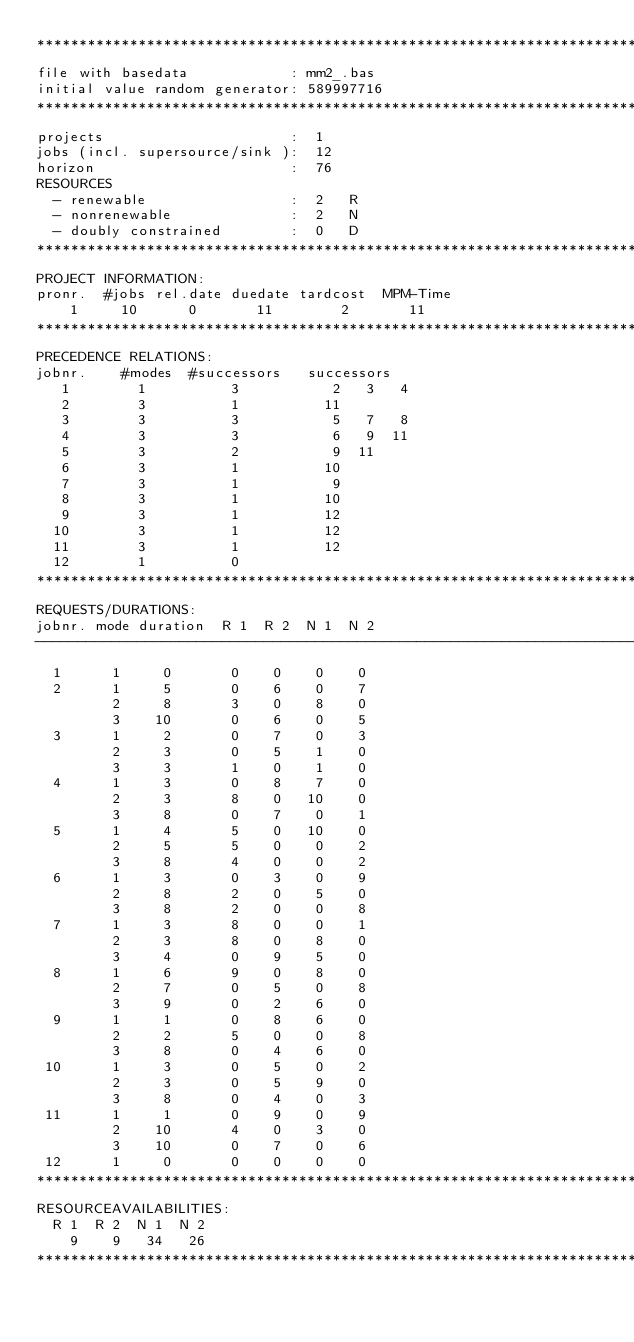<code> <loc_0><loc_0><loc_500><loc_500><_ObjectiveC_>************************************************************************
file with basedata            : mm2_.bas
initial value random generator: 589997716
************************************************************************
projects                      :  1
jobs (incl. supersource/sink ):  12
horizon                       :  76
RESOURCES
  - renewable                 :  2   R
  - nonrenewable              :  2   N
  - doubly constrained        :  0   D
************************************************************************
PROJECT INFORMATION:
pronr.  #jobs rel.date duedate tardcost  MPM-Time
    1     10      0       11        2       11
************************************************************************
PRECEDENCE RELATIONS:
jobnr.    #modes  #successors   successors
   1        1          3           2   3   4
   2        3          1          11
   3        3          3           5   7   8
   4        3          3           6   9  11
   5        3          2           9  11
   6        3          1          10
   7        3          1           9
   8        3          1          10
   9        3          1          12
  10        3          1          12
  11        3          1          12
  12        1          0        
************************************************************************
REQUESTS/DURATIONS:
jobnr. mode duration  R 1  R 2  N 1  N 2
------------------------------------------------------------------------
  1      1     0       0    0    0    0
  2      1     5       0    6    0    7
         2     8       3    0    8    0
         3    10       0    6    0    5
  3      1     2       0    7    0    3
         2     3       0    5    1    0
         3     3       1    0    1    0
  4      1     3       0    8    7    0
         2     3       8    0   10    0
         3     8       0    7    0    1
  5      1     4       5    0   10    0
         2     5       5    0    0    2
         3     8       4    0    0    2
  6      1     3       0    3    0    9
         2     8       2    0    5    0
         3     8       2    0    0    8
  7      1     3       8    0    0    1
         2     3       8    0    8    0
         3     4       0    9    5    0
  8      1     6       9    0    8    0
         2     7       0    5    0    8
         3     9       0    2    6    0
  9      1     1       0    8    6    0
         2     2       5    0    0    8
         3     8       0    4    6    0
 10      1     3       0    5    0    2
         2     3       0    5    9    0
         3     8       0    4    0    3
 11      1     1       0    9    0    9
         2    10       4    0    3    0
         3    10       0    7    0    6
 12      1     0       0    0    0    0
************************************************************************
RESOURCEAVAILABILITIES:
  R 1  R 2  N 1  N 2
    9    9   34   26
************************************************************************
</code> 